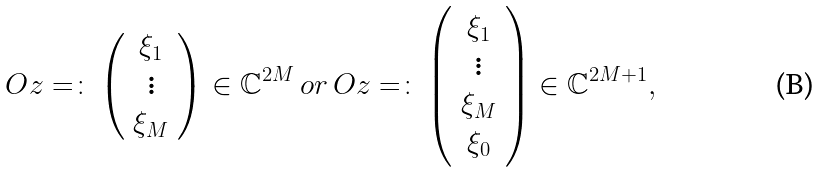<formula> <loc_0><loc_0><loc_500><loc_500>O z = \colon \left ( \begin{array} { c } \xi _ { 1 } \\ \vdots \\ \xi _ { M } \end{array} \right ) \in \mathbb { C } ^ { 2 M } \, o r \, O z = \colon \left ( \begin{array} { c } \xi _ { 1 } \\ \vdots \\ \xi _ { M } \\ \xi _ { 0 } \end{array} \right ) \in \mathbb { C } ^ { 2 M + 1 } ,</formula> 